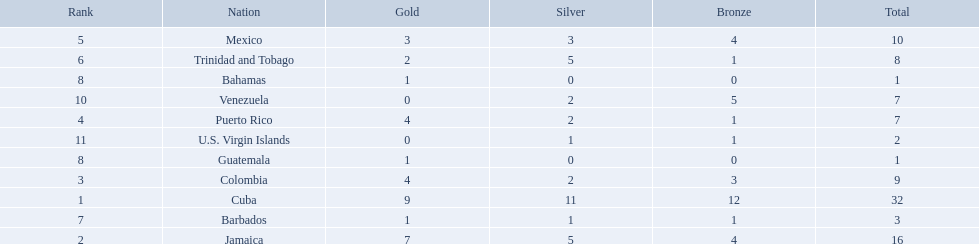Which 3 countries were awarded the most medals? Cuba, Jamaica, Colombia. Of these 3 countries which ones are islands? Cuba, Jamaica. Which one won the most silver medals? Cuba. 